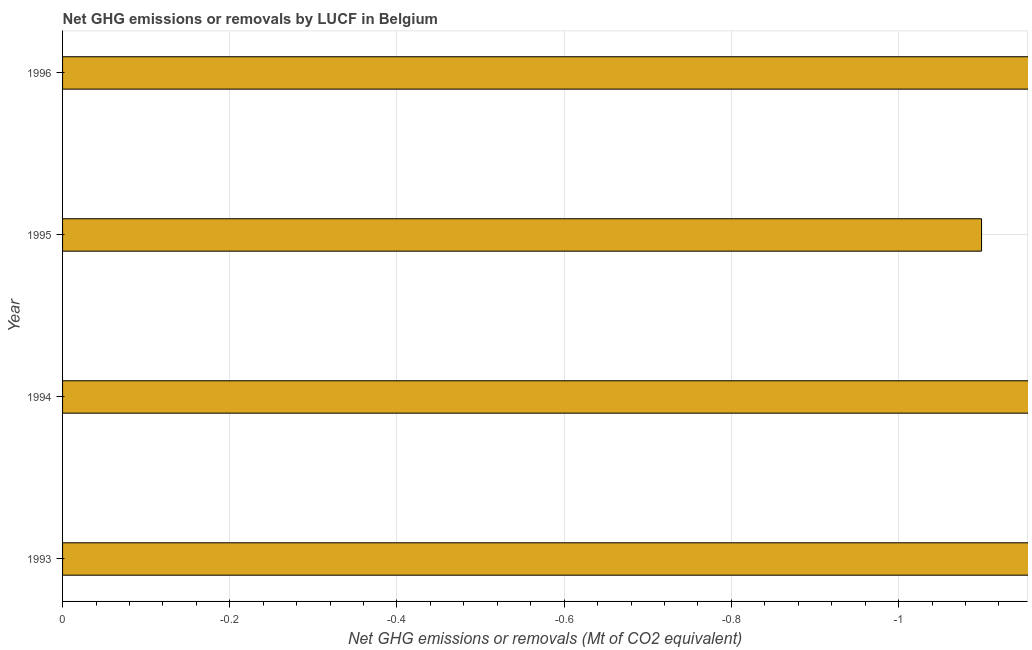Does the graph contain any zero values?
Your answer should be compact. Yes. Does the graph contain grids?
Offer a terse response. Yes. What is the title of the graph?
Your response must be concise. Net GHG emissions or removals by LUCF in Belgium. What is the label or title of the X-axis?
Offer a terse response. Net GHG emissions or removals (Mt of CO2 equivalent). What is the label or title of the Y-axis?
Your answer should be compact. Year. Across all years, what is the minimum ghg net emissions or removals?
Ensure brevity in your answer.  0. What is the average ghg net emissions or removals per year?
Your answer should be compact. 0. In how many years, is the ghg net emissions or removals greater than -0.72 Mt?
Your answer should be compact. 0. What is the difference between two consecutive major ticks on the X-axis?
Your answer should be compact. 0.2. Are the values on the major ticks of X-axis written in scientific E-notation?
Provide a short and direct response. No. What is the Net GHG emissions or removals (Mt of CO2 equivalent) in 1993?
Keep it short and to the point. 0. What is the Net GHG emissions or removals (Mt of CO2 equivalent) in 1995?
Make the answer very short. 0. What is the Net GHG emissions or removals (Mt of CO2 equivalent) in 1996?
Provide a short and direct response. 0. 